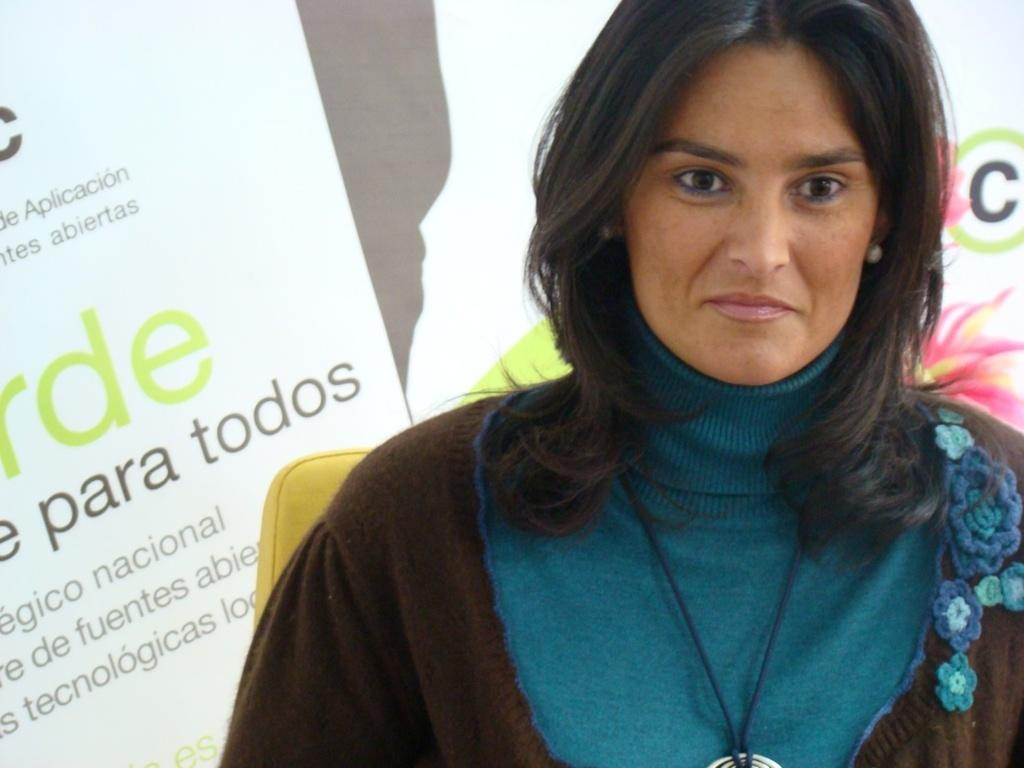Who is the main subject in the image? There is a woman in the image. Can you describe the woman's appearance? The woman has long hair and is wearing a dress. What is the woman doing in the image? The woman is sitting on a chair. What can be seen in the background of the image? There is a wall with text in the background of the image. What type of mint or cream is being used to decorate the woman's hair in the image? There is no mint or cream present in the woman's hair in the image. 